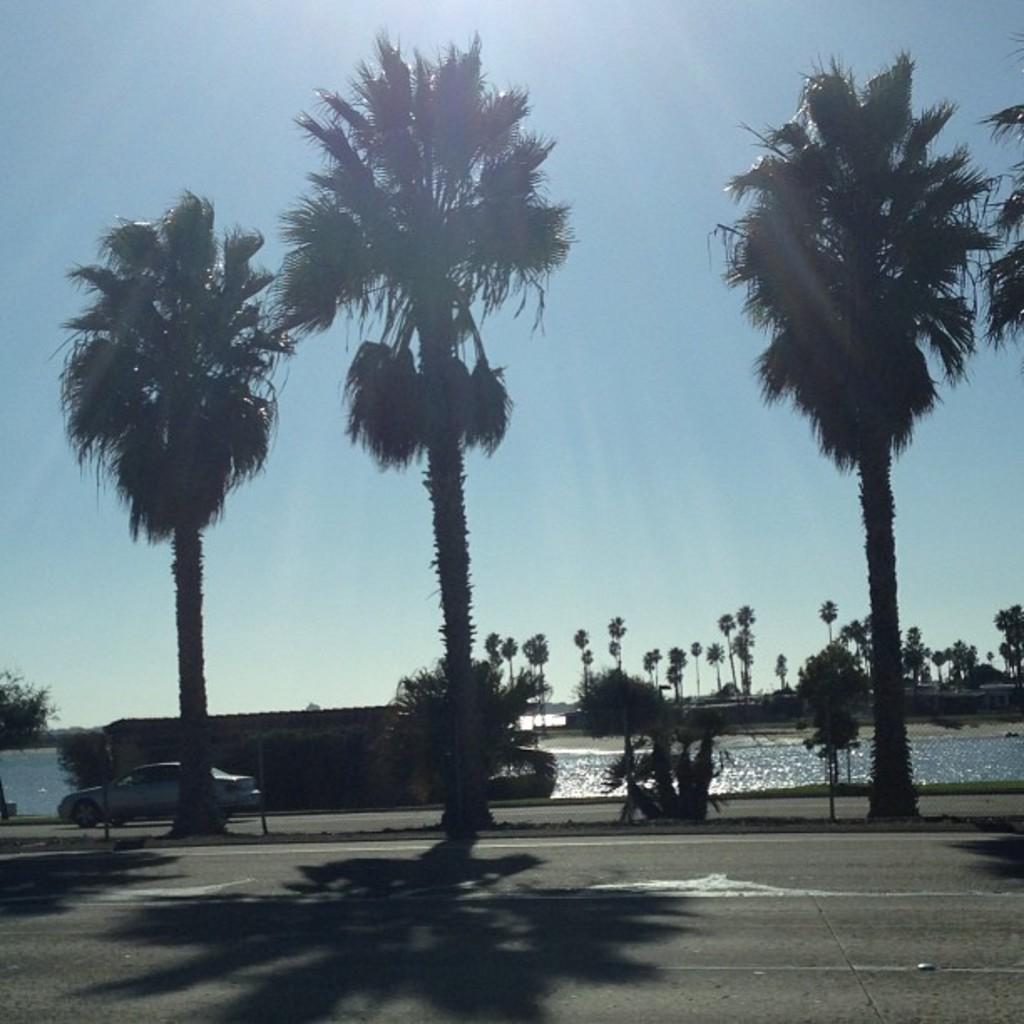Describe this image in one or two sentences. In this image there is a car on the road. In the center of the image there is water. There is a wall. In the background of the image there are trees and sky. 